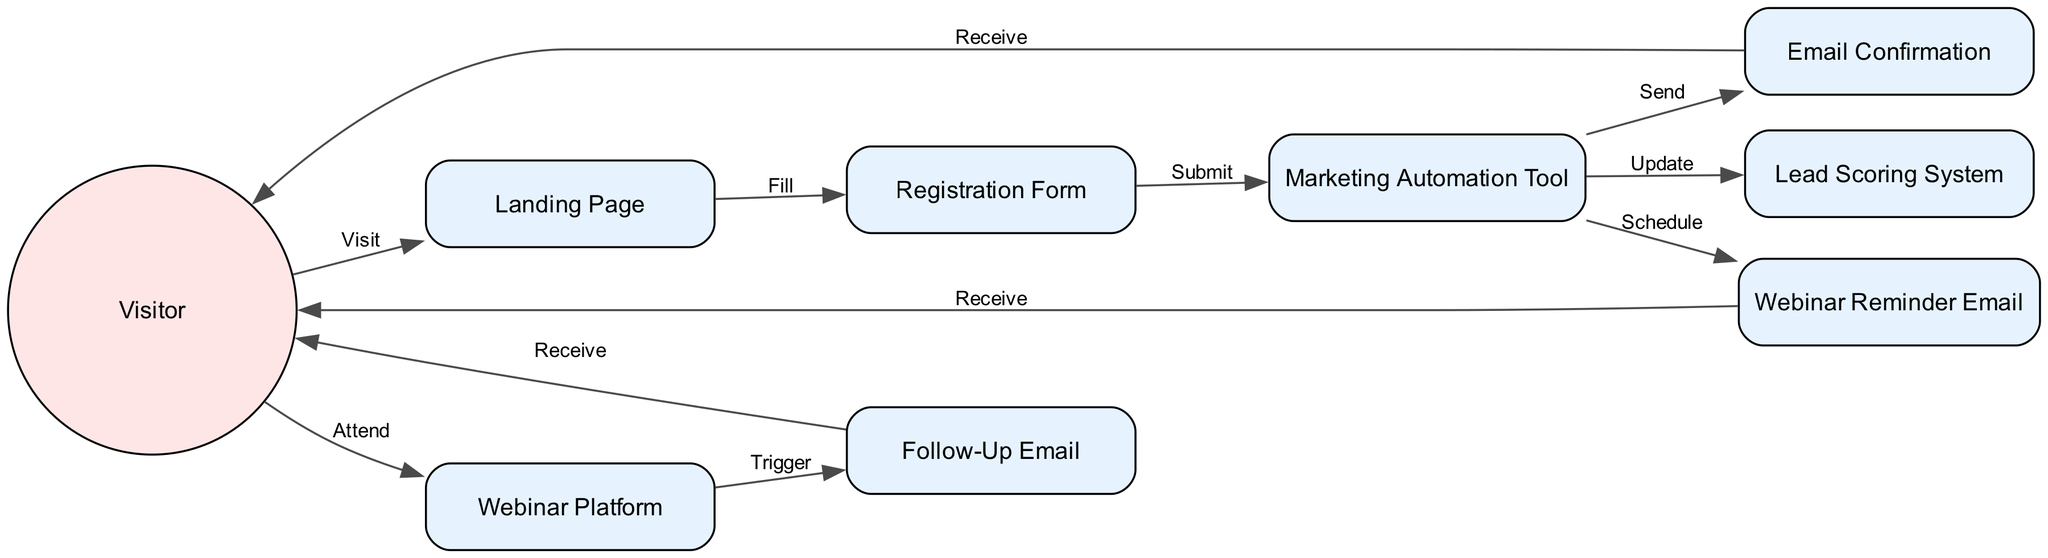What is the first action taken by the Visitor? The diagram shows that the Visitor starts the process by visiting the Landing Page. This is indicated by the first edge that connects the Visitor to the Landing Page, labeled "Visit."
Answer: Visit How many system components are involved in the diagram? The diagram lists the following system components: Landing Page, Registration Form, Marketing Automation Tool, Email Confirmation, Webinar Reminder Email, Webinar Platform, Follow-Up Email, and Lead Scoring System. Counting these, there are a total of eight system components.
Answer: Eight What action follows the Email Confirmation? After the Email Confirmation is sent, the Visitor receives it. This is shown by the edge connecting Email Confirmation to Visitor, labeled "Receive."
Answer: Receive What is the relationship between the Marketing Automation Tool and the Webinar Reminder Email? The diagram indicates that the Marketing Automation Tool schedules the Webinar Reminder Email, as shown by the edge labeled "Schedule" that connects these two components.
Answer: Schedule What is the last action taken by the Visitor in the sequence? The last action taken by the Visitor, according to the diagram, is receiving the Follow-Up Email. This is indicated by the edge connecting Follow-Up Email back to Visitor, labeled "Receive."
Answer: Receive Which component triggers the Follow-Up Email? The Webinar Platform is responsible for triggering the Follow-Up Email, as evidenced by the edge labeled "Trigger" that connects the Webinar Platform to Follow-Up Email.
Answer: Trigger How many edges connect the Visitor to other components? The Visitor is connected to three components through four edges: Landing Page, Webinar Platform, and Follow-Up Email. Therefore, there are a total of four edges connecting the Visitor to other components.
Answer: Four What role does the Lead Scoring System play in the process? The Lead Scoring System is updated by the Marketing Automation Tool, which is shown in the diagram by the edge labeled "Update" connecting these two components.
Answer: Update 